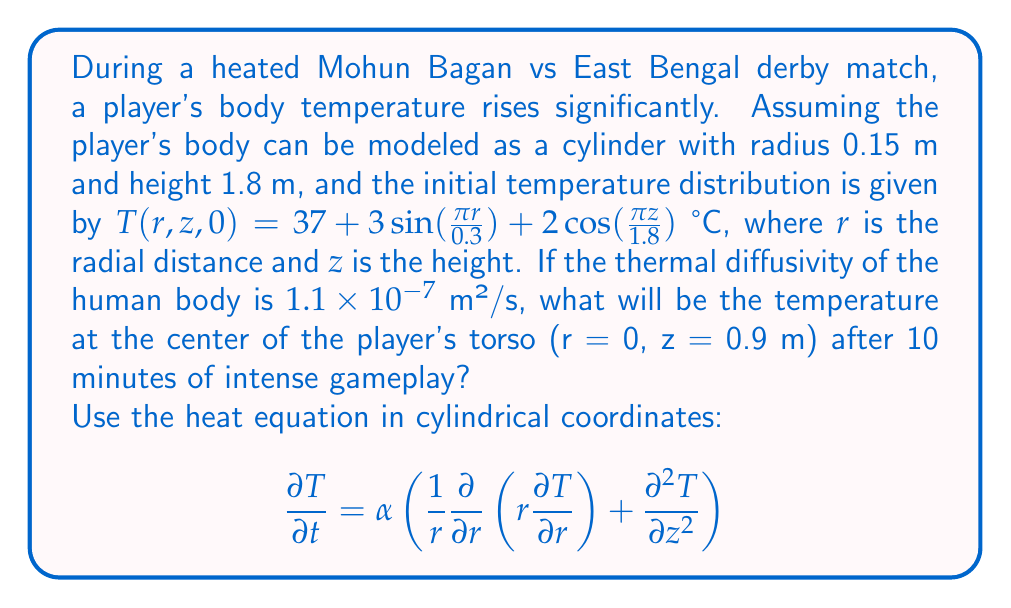Can you solve this math problem? Let's approach this step-by-step:

1) The heat equation in cylindrical coordinates is given. We need to solve this equation using separation of variables.

2) Assume $T(r,z,t) = R(r)Z(z)G(t)$

3) Substituting into the heat equation and separating variables:

   $$\frac{G'(t)}{\alpha G(t)} = \frac{1}{r R(r)}\frac{d}{dr}\left(r\frac{dR}{dr}\right) + \frac{1}{Z(z)}\frac{d^2Z}{dz^2} = -k^2$$

4) This leads to three equations:
   
   $$G'(t) + \alpha k^2 G(t) = 0$$
   $$\frac{d^2Z}{dz^2} + \lambda^2 Z = 0$$
   $$\frac{d}{dr}\left(r\frac{dR}{dr}\right) + (k^2 - \lambda^2)r R = 0$$

5) The solutions are:
   
   $$G(t) = e^{-\alpha k^2 t}$$
   $$Z(z) = A\cos(\lambda z) + B\sin(\lambda z)$$
   $$R(r) = C J_0(\mu r)$$

   where $k^2 = \lambda^2 + \mu^2$, and $J_0$ is the Bessel function of the first kind of order 0.

6) The general solution is:

   $$T(r,z,t) = \sum_{n=1}^{\infty}\sum_{m=1}^{\infty} C_{nm} J_0(\mu_n r) [A_{nm}\cos(\lambda_m z) + B_{nm}\sin(\lambda_m z)] e^{-\alpha (\mu_n^2 + \lambda_m^2)t}$$

7) From the initial condition, we can see that:

   $$\lambda_1 = \frac{\pi}{1.8}, \mu_1 = \frac{\pi}{0.3}$$

8) The initial condition can be written as:

   $$T(r,z,0) = 37 + 3J_0(\mu_1 r) + 2\cos(\lambda_1 z)$$

9) Therefore, our solution simplifies to:

   $$T(r,z,t) = 37 + 3J_0(\mu_1 r)e^{-\alpha \mu_1^2 t} + 2\cos(\lambda_1 z)e^{-\alpha \lambda_1^2 t}$$

10) At the center of the torso (r = 0, z = 0.9 m) after 10 minutes (600 seconds):

    $$T(0,0.9,600) = 37 + 3J_0(0)e^{-\alpha (\frac{\pi}{0.3})^2 600} + 2\cos(\frac{\pi 0.9}{1.8})e^{-\alpha (\frac{\pi}{1.8})^2 600}$$

11) Substituting the values:
    
    $$T(0,0.9,600) = 37 + 3e^{-1.1 \times 10^{-7} (\frac{\pi}{0.3})^2 600} + 2\cos(\frac{\pi}{2})e^{-1.1 \times 10^{-7} (\frac{\pi}{1.8})^2 600}$$

12) Calculating:

    $$T(0,0.9,600) = 37 + 3(0.0388) + 2(0)(0.9843) = 37.1164 \text{ °C}$$
Answer: 37.12 °C 